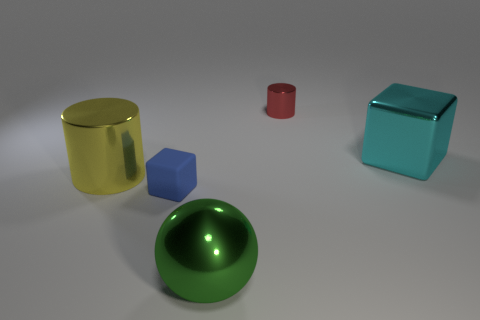What color is the tiny cylinder?
Your answer should be compact. Red. The large yellow thing that is the same material as the cyan cube is what shape?
Ensure brevity in your answer.  Cylinder. There is a shiny cylinder on the right side of the blue thing; does it have the same size as the green object?
Offer a very short reply. No. What number of things are either metallic objects in front of the yellow cylinder or metallic objects that are left of the big cyan object?
Provide a succinct answer. 3. There is a cylinder behind the large yellow metal thing; is it the same color as the large cylinder?
Give a very brief answer. No. What number of matte things are either small cubes or red cylinders?
Give a very brief answer. 1. The tiny blue object has what shape?
Keep it short and to the point. Cube. Is there any other thing that has the same material as the big cyan thing?
Offer a terse response. Yes. Are the big cube and the blue thing made of the same material?
Provide a short and direct response. No. There is a cube to the left of the cube that is right of the small metal cylinder; are there any tiny blue matte things that are behind it?
Your response must be concise. No. 